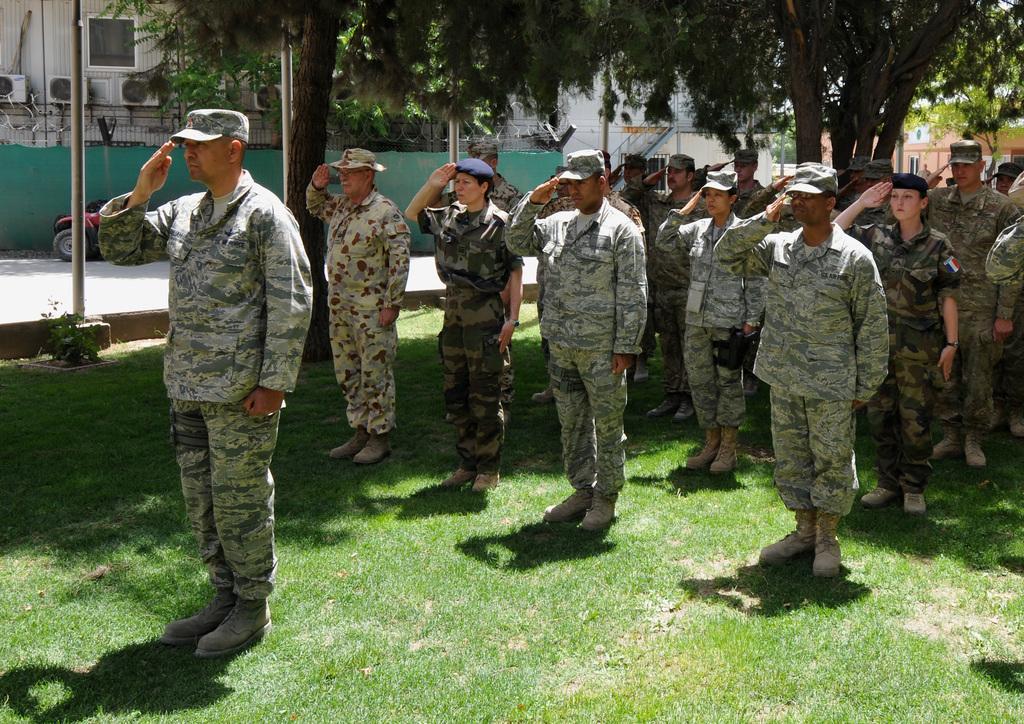Can you describe this image briefly? In this picture we can see some people standing and saluting, at the bottom there is grass, these people wore caps, in the background there is a building, we can see trees here, on the left side there is a pole. 